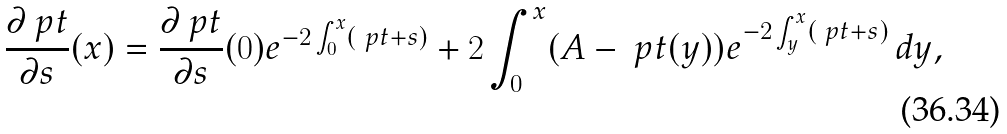Convert formula to latex. <formula><loc_0><loc_0><loc_500><loc_500>\frac { \partial { \ p t } } { \partial s } ( x ) = \frac { \partial { \ p t } } { \partial s } ( 0 ) e ^ { - 2 \int _ { 0 } ^ { x } ( \ p t + s ) } + 2 \int _ { 0 } ^ { x } ( A - \ p t ( y ) ) e ^ { - 2 \int _ { y } ^ { x } ( \ p t + s ) } \, d y ,</formula> 